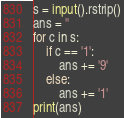Convert code to text. <code><loc_0><loc_0><loc_500><loc_500><_Python_>s = input().rstrip()
ans = ''
for c in s:
    if c == '1':
        ans += '9'
    else:
        ans += '1'
print(ans)
</code> 